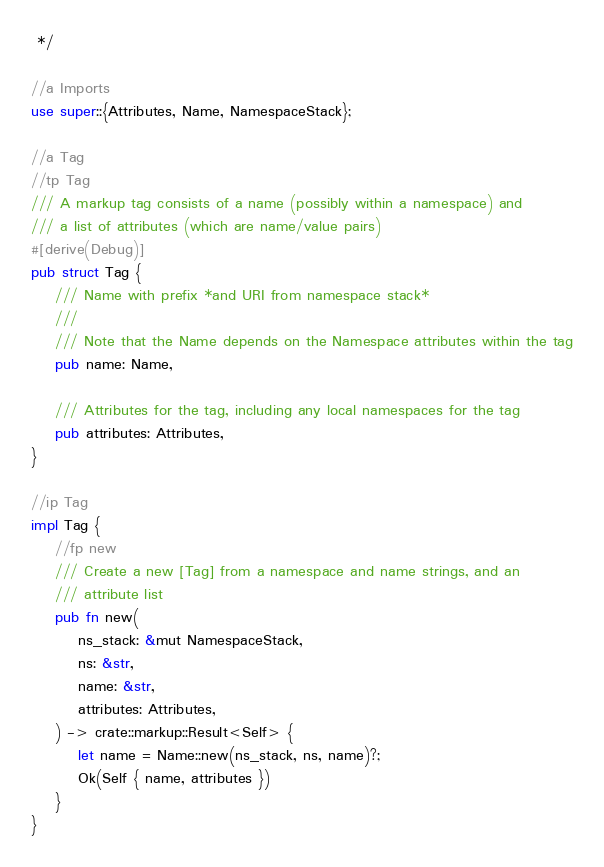Convert code to text. <code><loc_0><loc_0><loc_500><loc_500><_Rust_> */

//a Imports
use super::{Attributes, Name, NamespaceStack};

//a Tag
//tp Tag
/// A markup tag consists of a name (possibly within a namespace) and
/// a list of attributes (which are name/value pairs)
#[derive(Debug)]
pub struct Tag {
    /// Name with prefix *and URI from namespace stack*
    ///
    /// Note that the Name depends on the Namespace attributes within the tag
    pub name: Name,

    /// Attributes for the tag, including any local namespaces for the tag
    pub attributes: Attributes,
}

//ip Tag
impl Tag {
    //fp new
    /// Create a new [Tag] from a namespace and name strings, and an
    /// attribute list
    pub fn new(
        ns_stack: &mut NamespaceStack,
        ns: &str,
        name: &str,
        attributes: Attributes,
    ) -> crate::markup::Result<Self> {
        let name = Name::new(ns_stack, ns, name)?;
        Ok(Self { name, attributes })
    }
}
</code> 